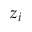Convert formula to latex. <formula><loc_0><loc_0><loc_500><loc_500>z _ { i }</formula> 